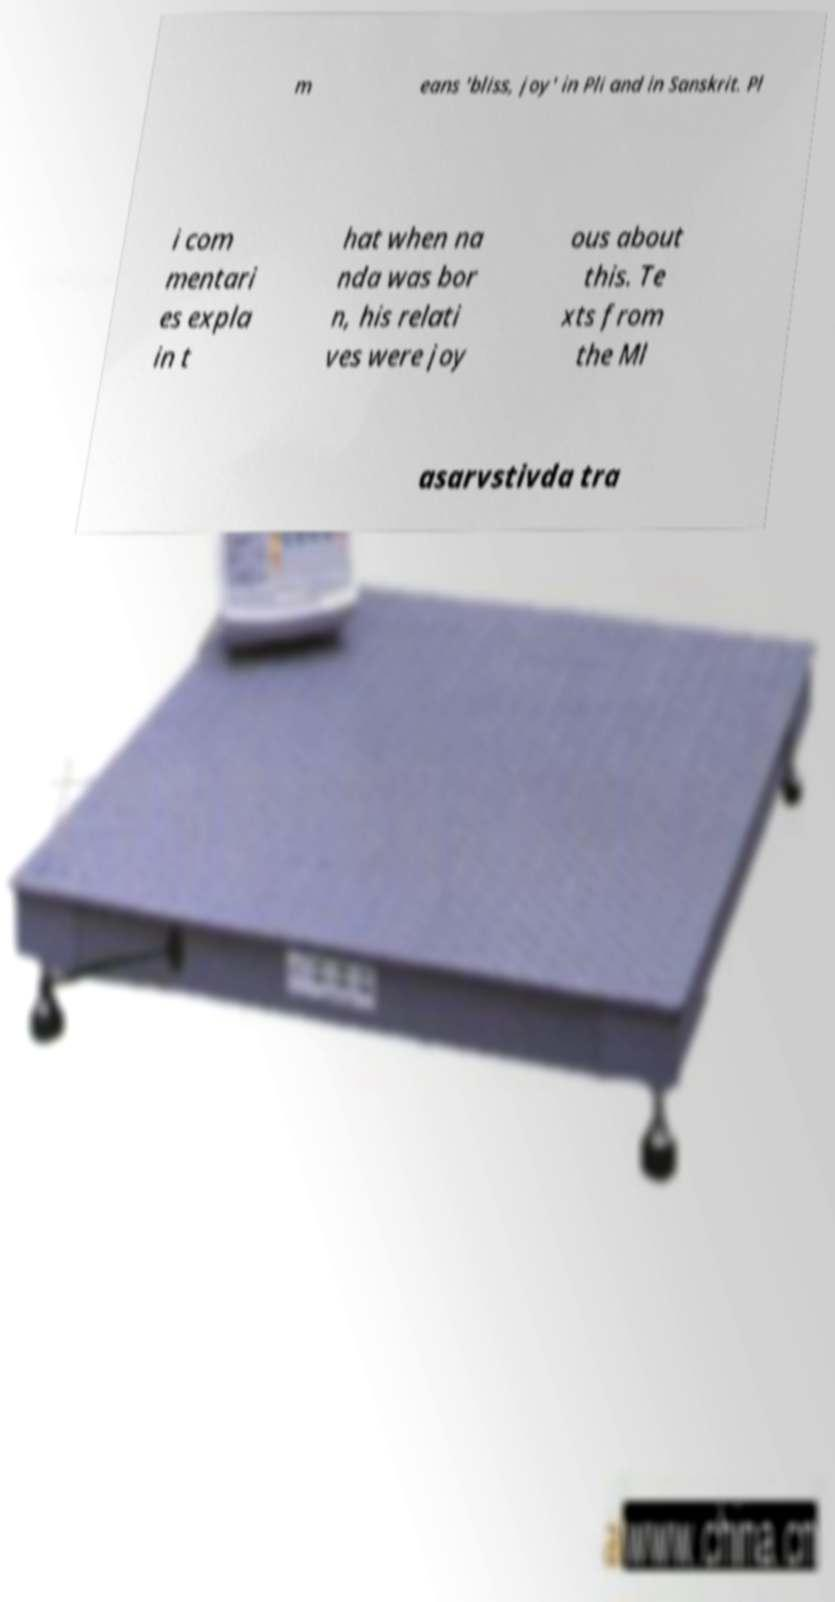Can you read and provide the text displayed in the image?This photo seems to have some interesting text. Can you extract and type it out for me? m eans 'bliss, joy' in Pli and in Sanskrit. Pl i com mentari es expla in t hat when na nda was bor n, his relati ves were joy ous about this. Te xts from the Ml asarvstivda tra 